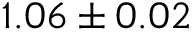<formula> <loc_0><loc_0><loc_500><loc_500>1 . 0 6 \pm 0 . 0 2</formula> 